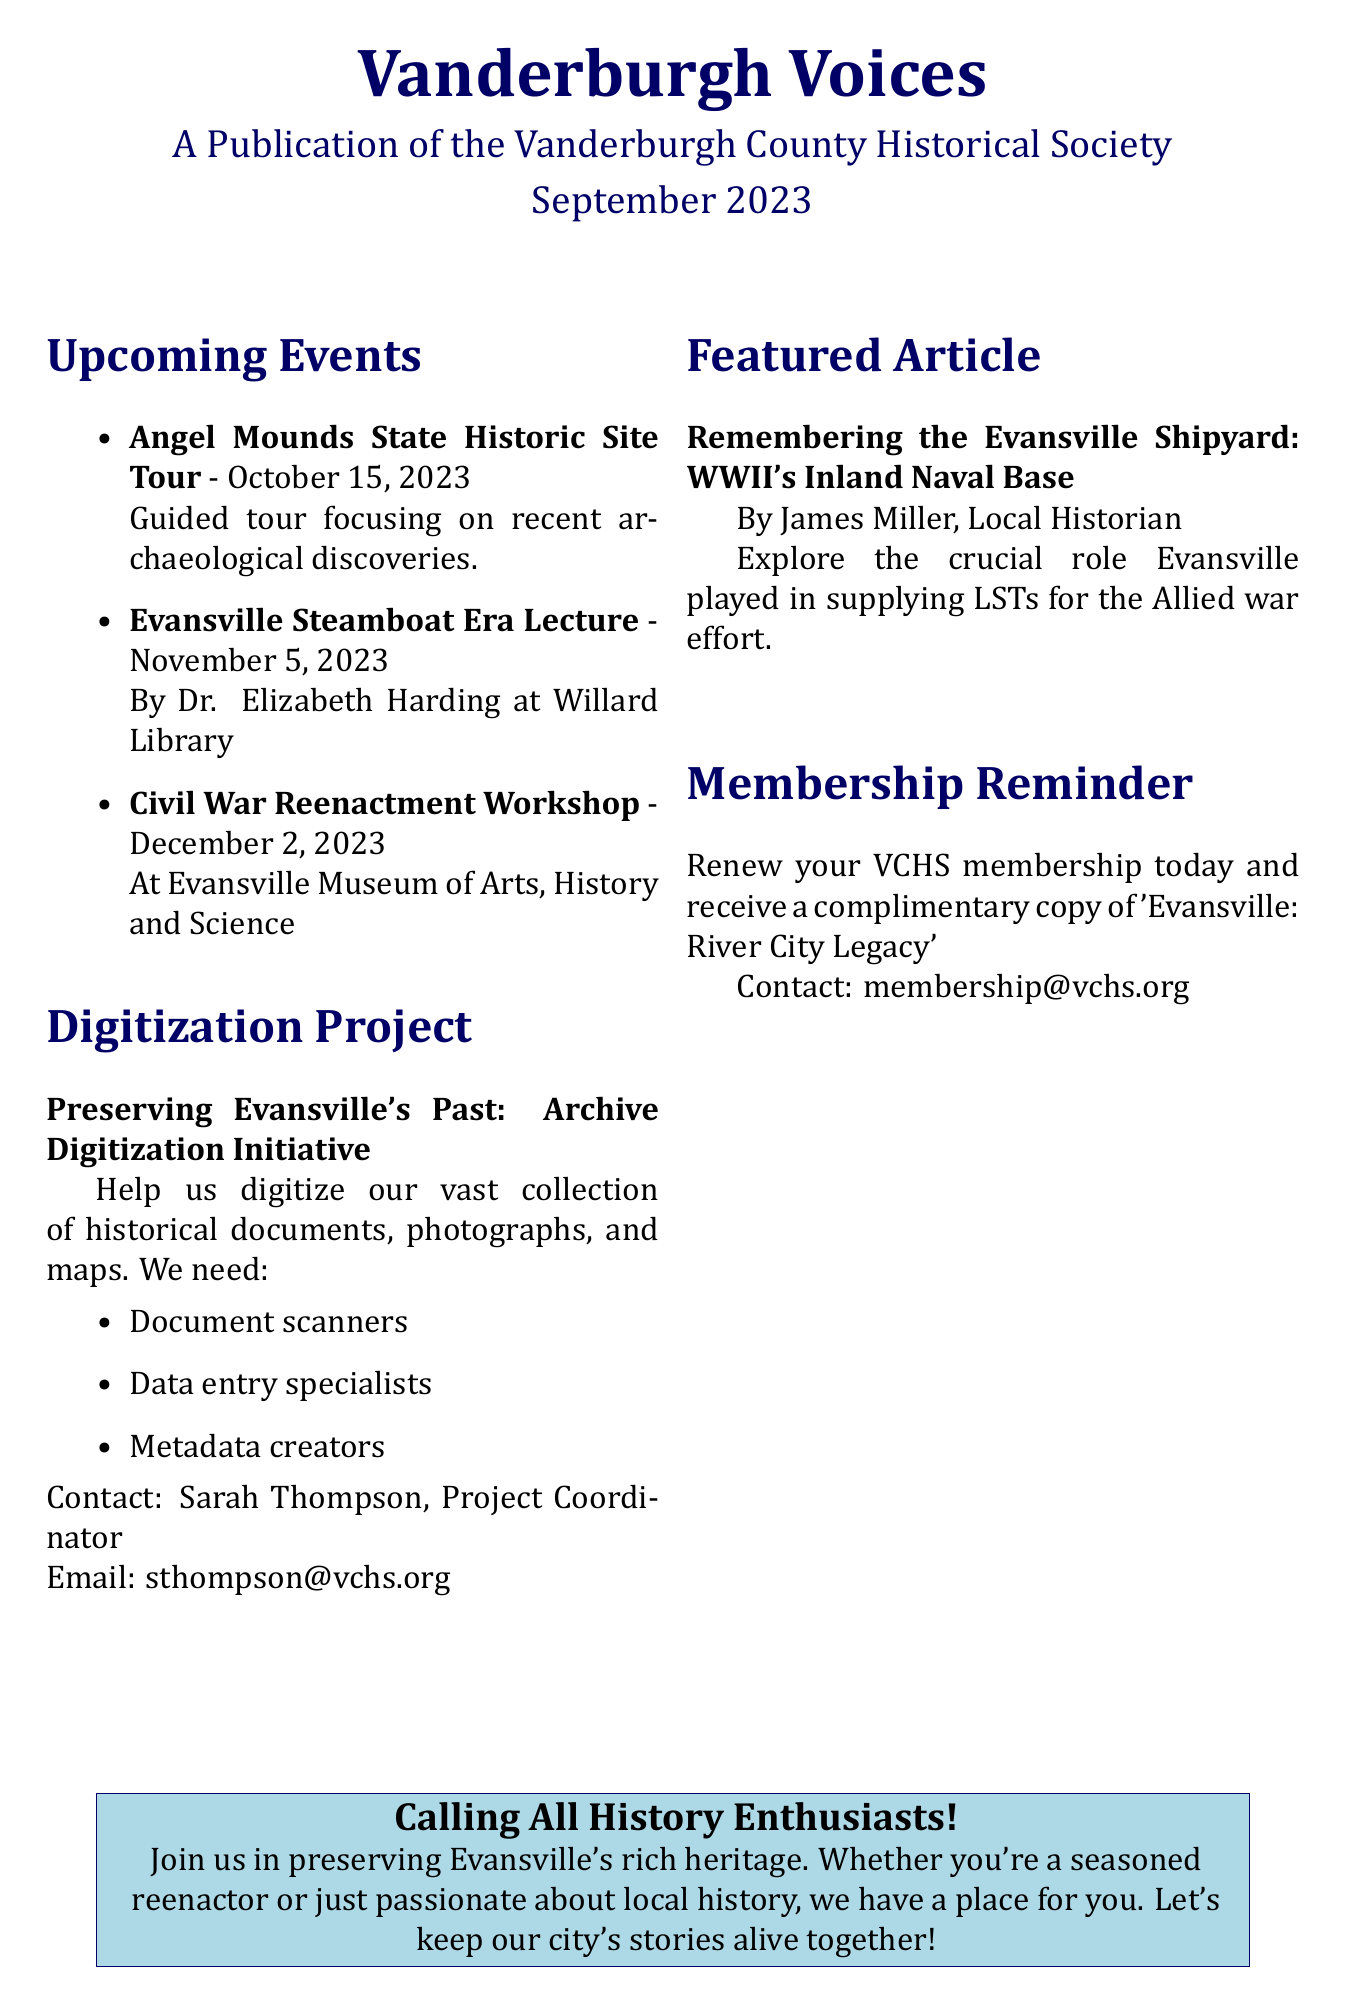What is the title of the newsletter? The title of the newsletter is prominently displayed at the top of the document.
Answer: Vanderburgh Voices What is the date of the Angel Mounds State Historic Site Tour? The date is specified next to the event name in the upcoming events section.
Answer: October 15, 2023 Who is the speaker for the Evansville Steamboat Era Lecture? The speaker's name is mentioned along with the event details in the upcoming events section.
Answer: Dr. Elizabeth Harding Where will the Civil War Reenactment Workshop take place? The location is provided with the event details in the upcoming events section.
Answer: Evansville Museum of Arts, History and Science What volunteer roles are needed for the digitization project? The document lists specific roles mentioned under the digitization project section.
Answer: Document scanners What is the main focus of the featured article? The teaser of the article provides insight into its subject matter.
Answer: Evansville Shipyard Who is the author of the featured article? The author's name is stated in the featured article section.
Answer: James Miller What is the email contact for membership inquiries? The email is provided in the membership reminder section.
Answer: membership@vchs.org What initiative seeks to preserve Evansville's historical documents? The title of the project is highlighted in the digitization project section.
Answer: Archive Digitization Initiative 